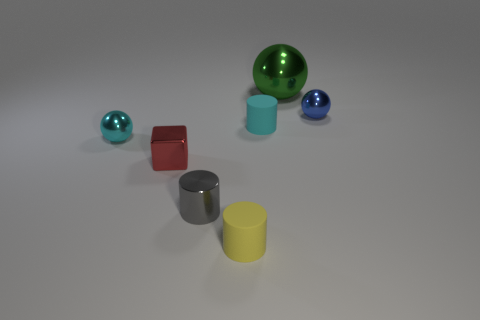How many cyan rubber objects are right of the yellow matte cylinder?
Offer a very short reply. 1. What is the shape of the other big object that is the same material as the blue thing?
Your response must be concise. Sphere. There is a cyan thing behind the small cyan metal thing; is it the same shape as the tiny red object?
Give a very brief answer. No. How many brown objects are spheres or small cylinders?
Offer a very short reply. 0. Are there the same number of tiny shiny spheres in front of the gray metal thing and matte cylinders in front of the tiny yellow object?
Ensure brevity in your answer.  Yes. The small ball right of the large thing to the right of the small shiny ball that is left of the big green shiny thing is what color?
Provide a short and direct response. Blue. Is there any other thing that has the same color as the tiny metallic cube?
Provide a short and direct response. No. There is a shiny object on the right side of the big green metal thing; what size is it?
Ensure brevity in your answer.  Small. What is the shape of the gray thing that is the same size as the red metallic object?
Offer a very short reply. Cylinder. Is the cylinder to the left of the yellow rubber object made of the same material as the tiny object in front of the tiny gray metallic cylinder?
Keep it short and to the point. No. 